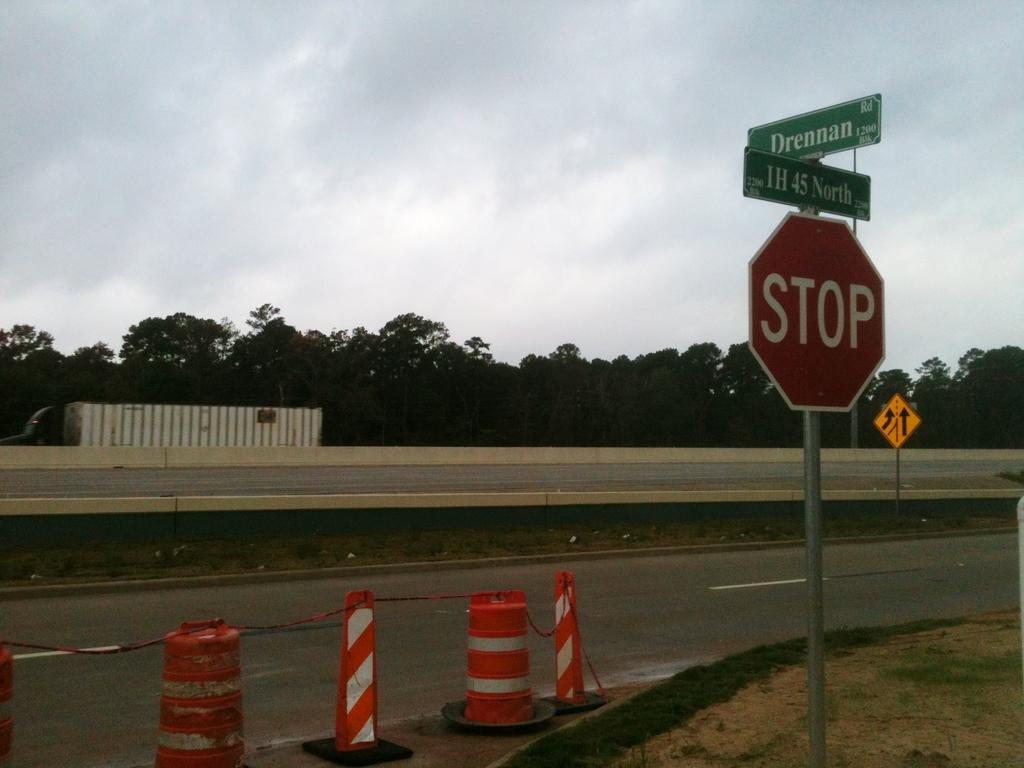What is the name of the road?
Provide a succinct answer. Ih 45 north. Will drennan take me to the highway?
Provide a succinct answer. Yes. 